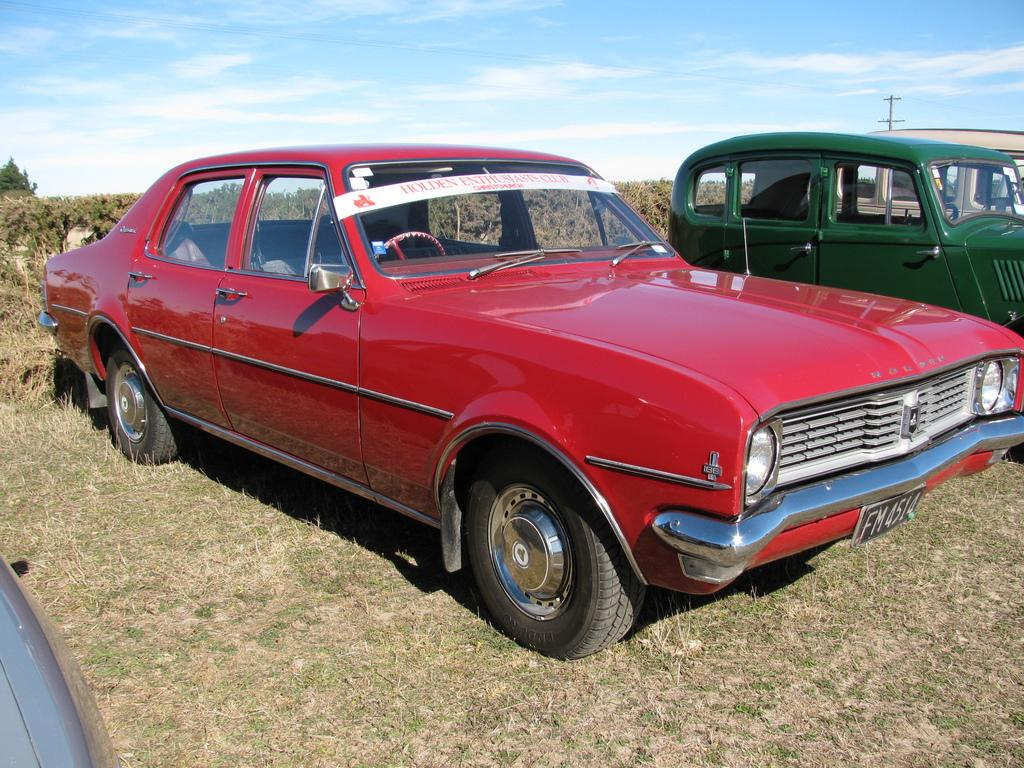What types of objects can be seen in the image? There are vehicles in the image. Can you describe the appearance of the vehicles? The vehicles are in different colors. What other elements can be seen in the image besides the vehicles? There are trees, the sky, and grass visible in the image. What unit of measurement is used to determine the level of the grass in the image? There is no indication of a specific unit of measurement being used to determine the level of the grass in the image. 